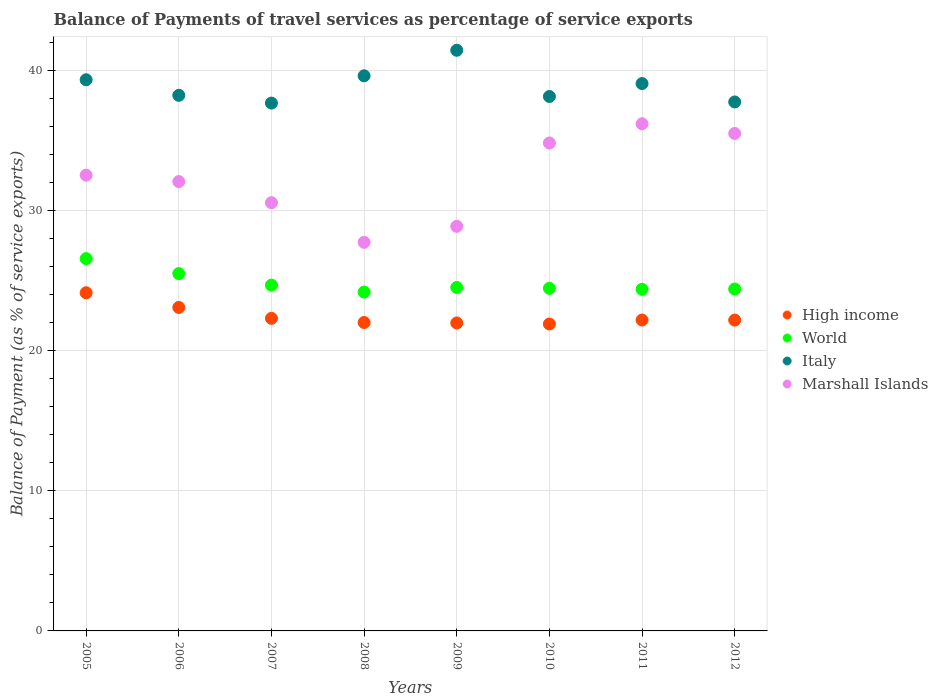How many different coloured dotlines are there?
Your response must be concise. 4. Is the number of dotlines equal to the number of legend labels?
Make the answer very short. Yes. What is the balance of payments of travel services in Italy in 2008?
Your answer should be compact. 39.66. Across all years, what is the maximum balance of payments of travel services in Marshall Islands?
Your response must be concise. 36.23. Across all years, what is the minimum balance of payments of travel services in Marshall Islands?
Make the answer very short. 27.76. What is the total balance of payments of travel services in Marshall Islands in the graph?
Make the answer very short. 258.53. What is the difference between the balance of payments of travel services in World in 2006 and that in 2012?
Make the answer very short. 1.1. What is the difference between the balance of payments of travel services in Italy in 2008 and the balance of payments of travel services in High income in 2012?
Provide a succinct answer. 17.45. What is the average balance of payments of travel services in Italy per year?
Offer a very short reply. 38.94. In the year 2005, what is the difference between the balance of payments of travel services in Marshall Islands and balance of payments of travel services in High income?
Provide a succinct answer. 8.4. In how many years, is the balance of payments of travel services in Italy greater than 34 %?
Provide a short and direct response. 8. What is the ratio of the balance of payments of travel services in High income in 2008 to that in 2010?
Provide a succinct answer. 1. Is the balance of payments of travel services in High income in 2005 less than that in 2011?
Provide a short and direct response. No. What is the difference between the highest and the second highest balance of payments of travel services in World?
Offer a very short reply. 1.07. What is the difference between the highest and the lowest balance of payments of travel services in Italy?
Offer a very short reply. 3.77. In how many years, is the balance of payments of travel services in Italy greater than the average balance of payments of travel services in Italy taken over all years?
Make the answer very short. 4. Is the sum of the balance of payments of travel services in High income in 2005 and 2006 greater than the maximum balance of payments of travel services in Marshall Islands across all years?
Offer a very short reply. Yes. Is it the case that in every year, the sum of the balance of payments of travel services in World and balance of payments of travel services in Marshall Islands  is greater than the sum of balance of payments of travel services in Italy and balance of payments of travel services in High income?
Keep it short and to the point. Yes. Is the balance of payments of travel services in World strictly greater than the balance of payments of travel services in High income over the years?
Give a very brief answer. Yes. How many dotlines are there?
Offer a terse response. 4. How many years are there in the graph?
Your response must be concise. 8. What is the difference between two consecutive major ticks on the Y-axis?
Offer a very short reply. 10. Are the values on the major ticks of Y-axis written in scientific E-notation?
Make the answer very short. No. Does the graph contain grids?
Make the answer very short. Yes. How many legend labels are there?
Ensure brevity in your answer.  4. What is the title of the graph?
Provide a succinct answer. Balance of Payments of travel services as percentage of service exports. What is the label or title of the X-axis?
Offer a terse response. Years. What is the label or title of the Y-axis?
Give a very brief answer. Balance of Payment (as % of service exports). What is the Balance of Payment (as % of service exports) in High income in 2005?
Provide a short and direct response. 24.16. What is the Balance of Payment (as % of service exports) in World in 2005?
Your answer should be very brief. 26.59. What is the Balance of Payment (as % of service exports) in Italy in 2005?
Keep it short and to the point. 39.37. What is the Balance of Payment (as % of service exports) of Marshall Islands in 2005?
Your response must be concise. 32.56. What is the Balance of Payment (as % of service exports) in High income in 2006?
Ensure brevity in your answer.  23.11. What is the Balance of Payment (as % of service exports) in World in 2006?
Make the answer very short. 25.53. What is the Balance of Payment (as % of service exports) in Italy in 2006?
Offer a terse response. 38.26. What is the Balance of Payment (as % of service exports) in Marshall Islands in 2006?
Offer a terse response. 32.1. What is the Balance of Payment (as % of service exports) of High income in 2007?
Give a very brief answer. 22.33. What is the Balance of Payment (as % of service exports) in World in 2007?
Offer a terse response. 24.7. What is the Balance of Payment (as % of service exports) of Italy in 2007?
Ensure brevity in your answer.  37.71. What is the Balance of Payment (as % of service exports) of Marshall Islands in 2007?
Provide a succinct answer. 30.59. What is the Balance of Payment (as % of service exports) of High income in 2008?
Offer a very short reply. 22.03. What is the Balance of Payment (as % of service exports) of World in 2008?
Offer a very short reply. 24.21. What is the Balance of Payment (as % of service exports) of Italy in 2008?
Make the answer very short. 39.66. What is the Balance of Payment (as % of service exports) of Marshall Islands in 2008?
Offer a very short reply. 27.76. What is the Balance of Payment (as % of service exports) in High income in 2009?
Your answer should be compact. 22. What is the Balance of Payment (as % of service exports) in World in 2009?
Offer a terse response. 24.54. What is the Balance of Payment (as % of service exports) of Italy in 2009?
Give a very brief answer. 41.48. What is the Balance of Payment (as % of service exports) in Marshall Islands in 2009?
Offer a very short reply. 28.9. What is the Balance of Payment (as % of service exports) in High income in 2010?
Ensure brevity in your answer.  21.93. What is the Balance of Payment (as % of service exports) of World in 2010?
Provide a succinct answer. 24.47. What is the Balance of Payment (as % of service exports) in Italy in 2010?
Offer a terse response. 38.18. What is the Balance of Payment (as % of service exports) in Marshall Islands in 2010?
Make the answer very short. 34.86. What is the Balance of Payment (as % of service exports) in High income in 2011?
Keep it short and to the point. 22.21. What is the Balance of Payment (as % of service exports) of World in 2011?
Your answer should be very brief. 24.4. What is the Balance of Payment (as % of service exports) in Italy in 2011?
Offer a terse response. 39.1. What is the Balance of Payment (as % of service exports) of Marshall Islands in 2011?
Ensure brevity in your answer.  36.23. What is the Balance of Payment (as % of service exports) of High income in 2012?
Keep it short and to the point. 22.2. What is the Balance of Payment (as % of service exports) of World in 2012?
Your response must be concise. 24.42. What is the Balance of Payment (as % of service exports) in Italy in 2012?
Your response must be concise. 37.79. What is the Balance of Payment (as % of service exports) in Marshall Islands in 2012?
Your answer should be compact. 35.54. Across all years, what is the maximum Balance of Payment (as % of service exports) of High income?
Give a very brief answer. 24.16. Across all years, what is the maximum Balance of Payment (as % of service exports) in World?
Your response must be concise. 26.59. Across all years, what is the maximum Balance of Payment (as % of service exports) in Italy?
Provide a succinct answer. 41.48. Across all years, what is the maximum Balance of Payment (as % of service exports) of Marshall Islands?
Give a very brief answer. 36.23. Across all years, what is the minimum Balance of Payment (as % of service exports) in High income?
Ensure brevity in your answer.  21.93. Across all years, what is the minimum Balance of Payment (as % of service exports) of World?
Provide a succinct answer. 24.21. Across all years, what is the minimum Balance of Payment (as % of service exports) in Italy?
Offer a terse response. 37.71. Across all years, what is the minimum Balance of Payment (as % of service exports) in Marshall Islands?
Give a very brief answer. 27.76. What is the total Balance of Payment (as % of service exports) of High income in the graph?
Provide a short and direct response. 179.97. What is the total Balance of Payment (as % of service exports) of World in the graph?
Your answer should be compact. 198.87. What is the total Balance of Payment (as % of service exports) in Italy in the graph?
Offer a very short reply. 311.55. What is the total Balance of Payment (as % of service exports) of Marshall Islands in the graph?
Your answer should be very brief. 258.53. What is the difference between the Balance of Payment (as % of service exports) of High income in 2005 and that in 2006?
Keep it short and to the point. 1.05. What is the difference between the Balance of Payment (as % of service exports) of World in 2005 and that in 2006?
Your answer should be compact. 1.07. What is the difference between the Balance of Payment (as % of service exports) in Italy in 2005 and that in 2006?
Provide a succinct answer. 1.11. What is the difference between the Balance of Payment (as % of service exports) of Marshall Islands in 2005 and that in 2006?
Offer a very short reply. 0.46. What is the difference between the Balance of Payment (as % of service exports) in High income in 2005 and that in 2007?
Provide a short and direct response. 1.83. What is the difference between the Balance of Payment (as % of service exports) of World in 2005 and that in 2007?
Provide a succinct answer. 1.89. What is the difference between the Balance of Payment (as % of service exports) of Italy in 2005 and that in 2007?
Ensure brevity in your answer.  1.67. What is the difference between the Balance of Payment (as % of service exports) in Marshall Islands in 2005 and that in 2007?
Keep it short and to the point. 1.97. What is the difference between the Balance of Payment (as % of service exports) in High income in 2005 and that in 2008?
Provide a short and direct response. 2.13. What is the difference between the Balance of Payment (as % of service exports) in World in 2005 and that in 2008?
Give a very brief answer. 2.39. What is the difference between the Balance of Payment (as % of service exports) in Italy in 2005 and that in 2008?
Ensure brevity in your answer.  -0.28. What is the difference between the Balance of Payment (as % of service exports) of Marshall Islands in 2005 and that in 2008?
Your answer should be compact. 4.8. What is the difference between the Balance of Payment (as % of service exports) of High income in 2005 and that in 2009?
Give a very brief answer. 2.16. What is the difference between the Balance of Payment (as % of service exports) of World in 2005 and that in 2009?
Keep it short and to the point. 2.06. What is the difference between the Balance of Payment (as % of service exports) in Italy in 2005 and that in 2009?
Ensure brevity in your answer.  -2.11. What is the difference between the Balance of Payment (as % of service exports) of Marshall Islands in 2005 and that in 2009?
Give a very brief answer. 3.65. What is the difference between the Balance of Payment (as % of service exports) in High income in 2005 and that in 2010?
Ensure brevity in your answer.  2.23. What is the difference between the Balance of Payment (as % of service exports) in World in 2005 and that in 2010?
Your response must be concise. 2.12. What is the difference between the Balance of Payment (as % of service exports) in Italy in 2005 and that in 2010?
Ensure brevity in your answer.  1.19. What is the difference between the Balance of Payment (as % of service exports) in Marshall Islands in 2005 and that in 2010?
Give a very brief answer. -2.3. What is the difference between the Balance of Payment (as % of service exports) in High income in 2005 and that in 2011?
Keep it short and to the point. 1.95. What is the difference between the Balance of Payment (as % of service exports) in World in 2005 and that in 2011?
Your answer should be compact. 2.19. What is the difference between the Balance of Payment (as % of service exports) of Italy in 2005 and that in 2011?
Provide a short and direct response. 0.27. What is the difference between the Balance of Payment (as % of service exports) in Marshall Islands in 2005 and that in 2011?
Make the answer very short. -3.67. What is the difference between the Balance of Payment (as % of service exports) of High income in 2005 and that in 2012?
Make the answer very short. 1.95. What is the difference between the Balance of Payment (as % of service exports) of World in 2005 and that in 2012?
Offer a terse response. 2.17. What is the difference between the Balance of Payment (as % of service exports) in Italy in 2005 and that in 2012?
Give a very brief answer. 1.59. What is the difference between the Balance of Payment (as % of service exports) of Marshall Islands in 2005 and that in 2012?
Provide a short and direct response. -2.98. What is the difference between the Balance of Payment (as % of service exports) of High income in 2006 and that in 2007?
Your answer should be very brief. 0.78. What is the difference between the Balance of Payment (as % of service exports) of World in 2006 and that in 2007?
Keep it short and to the point. 0.82. What is the difference between the Balance of Payment (as % of service exports) of Italy in 2006 and that in 2007?
Keep it short and to the point. 0.55. What is the difference between the Balance of Payment (as % of service exports) in Marshall Islands in 2006 and that in 2007?
Offer a terse response. 1.51. What is the difference between the Balance of Payment (as % of service exports) in High income in 2006 and that in 2008?
Ensure brevity in your answer.  1.08. What is the difference between the Balance of Payment (as % of service exports) of World in 2006 and that in 2008?
Your response must be concise. 1.32. What is the difference between the Balance of Payment (as % of service exports) of Italy in 2006 and that in 2008?
Your answer should be compact. -1.4. What is the difference between the Balance of Payment (as % of service exports) in Marshall Islands in 2006 and that in 2008?
Give a very brief answer. 4.34. What is the difference between the Balance of Payment (as % of service exports) in High income in 2006 and that in 2009?
Give a very brief answer. 1.11. What is the difference between the Balance of Payment (as % of service exports) in World in 2006 and that in 2009?
Provide a succinct answer. 0.99. What is the difference between the Balance of Payment (as % of service exports) of Italy in 2006 and that in 2009?
Your answer should be very brief. -3.22. What is the difference between the Balance of Payment (as % of service exports) in Marshall Islands in 2006 and that in 2009?
Offer a very short reply. 3.2. What is the difference between the Balance of Payment (as % of service exports) of High income in 2006 and that in 2010?
Give a very brief answer. 1.18. What is the difference between the Balance of Payment (as % of service exports) in World in 2006 and that in 2010?
Make the answer very short. 1.05. What is the difference between the Balance of Payment (as % of service exports) of Italy in 2006 and that in 2010?
Your answer should be compact. 0.08. What is the difference between the Balance of Payment (as % of service exports) of Marshall Islands in 2006 and that in 2010?
Make the answer very short. -2.76. What is the difference between the Balance of Payment (as % of service exports) in High income in 2006 and that in 2011?
Ensure brevity in your answer.  0.9. What is the difference between the Balance of Payment (as % of service exports) in World in 2006 and that in 2011?
Offer a very short reply. 1.12. What is the difference between the Balance of Payment (as % of service exports) of Italy in 2006 and that in 2011?
Provide a short and direct response. -0.84. What is the difference between the Balance of Payment (as % of service exports) of Marshall Islands in 2006 and that in 2011?
Keep it short and to the point. -4.13. What is the difference between the Balance of Payment (as % of service exports) of High income in 2006 and that in 2012?
Your response must be concise. 0.9. What is the difference between the Balance of Payment (as % of service exports) of World in 2006 and that in 2012?
Provide a succinct answer. 1.1. What is the difference between the Balance of Payment (as % of service exports) of Italy in 2006 and that in 2012?
Offer a very short reply. 0.47. What is the difference between the Balance of Payment (as % of service exports) of Marshall Islands in 2006 and that in 2012?
Your answer should be compact. -3.44. What is the difference between the Balance of Payment (as % of service exports) in High income in 2007 and that in 2008?
Your answer should be very brief. 0.3. What is the difference between the Balance of Payment (as % of service exports) of World in 2007 and that in 2008?
Provide a short and direct response. 0.5. What is the difference between the Balance of Payment (as % of service exports) of Italy in 2007 and that in 2008?
Provide a short and direct response. -1.95. What is the difference between the Balance of Payment (as % of service exports) in Marshall Islands in 2007 and that in 2008?
Your answer should be very brief. 2.83. What is the difference between the Balance of Payment (as % of service exports) in High income in 2007 and that in 2009?
Provide a succinct answer. 0.33. What is the difference between the Balance of Payment (as % of service exports) in World in 2007 and that in 2009?
Your answer should be very brief. 0.17. What is the difference between the Balance of Payment (as % of service exports) of Italy in 2007 and that in 2009?
Offer a terse response. -3.77. What is the difference between the Balance of Payment (as % of service exports) in Marshall Islands in 2007 and that in 2009?
Offer a terse response. 1.69. What is the difference between the Balance of Payment (as % of service exports) in High income in 2007 and that in 2010?
Your answer should be compact. 0.4. What is the difference between the Balance of Payment (as % of service exports) in World in 2007 and that in 2010?
Provide a short and direct response. 0.23. What is the difference between the Balance of Payment (as % of service exports) in Italy in 2007 and that in 2010?
Offer a terse response. -0.47. What is the difference between the Balance of Payment (as % of service exports) of Marshall Islands in 2007 and that in 2010?
Offer a very short reply. -4.27. What is the difference between the Balance of Payment (as % of service exports) of High income in 2007 and that in 2011?
Your answer should be very brief. 0.12. What is the difference between the Balance of Payment (as % of service exports) in World in 2007 and that in 2011?
Provide a succinct answer. 0.3. What is the difference between the Balance of Payment (as % of service exports) of Italy in 2007 and that in 2011?
Ensure brevity in your answer.  -1.39. What is the difference between the Balance of Payment (as % of service exports) in Marshall Islands in 2007 and that in 2011?
Your response must be concise. -5.64. What is the difference between the Balance of Payment (as % of service exports) of High income in 2007 and that in 2012?
Keep it short and to the point. 0.13. What is the difference between the Balance of Payment (as % of service exports) of World in 2007 and that in 2012?
Provide a succinct answer. 0.28. What is the difference between the Balance of Payment (as % of service exports) of Italy in 2007 and that in 2012?
Your answer should be very brief. -0.08. What is the difference between the Balance of Payment (as % of service exports) in Marshall Islands in 2007 and that in 2012?
Make the answer very short. -4.95. What is the difference between the Balance of Payment (as % of service exports) in High income in 2008 and that in 2009?
Ensure brevity in your answer.  0.03. What is the difference between the Balance of Payment (as % of service exports) in World in 2008 and that in 2009?
Provide a short and direct response. -0.33. What is the difference between the Balance of Payment (as % of service exports) of Italy in 2008 and that in 2009?
Provide a succinct answer. -1.82. What is the difference between the Balance of Payment (as % of service exports) of Marshall Islands in 2008 and that in 2009?
Ensure brevity in your answer.  -1.14. What is the difference between the Balance of Payment (as % of service exports) in High income in 2008 and that in 2010?
Your answer should be very brief. 0.11. What is the difference between the Balance of Payment (as % of service exports) of World in 2008 and that in 2010?
Keep it short and to the point. -0.27. What is the difference between the Balance of Payment (as % of service exports) of Italy in 2008 and that in 2010?
Your answer should be compact. 1.48. What is the difference between the Balance of Payment (as % of service exports) of Marshall Islands in 2008 and that in 2010?
Ensure brevity in your answer.  -7.1. What is the difference between the Balance of Payment (as % of service exports) of High income in 2008 and that in 2011?
Your answer should be compact. -0.18. What is the difference between the Balance of Payment (as % of service exports) in World in 2008 and that in 2011?
Provide a succinct answer. -0.19. What is the difference between the Balance of Payment (as % of service exports) in Italy in 2008 and that in 2011?
Keep it short and to the point. 0.56. What is the difference between the Balance of Payment (as % of service exports) in Marshall Islands in 2008 and that in 2011?
Offer a terse response. -8.47. What is the difference between the Balance of Payment (as % of service exports) of High income in 2008 and that in 2012?
Offer a very short reply. -0.17. What is the difference between the Balance of Payment (as % of service exports) of World in 2008 and that in 2012?
Your response must be concise. -0.22. What is the difference between the Balance of Payment (as % of service exports) in Italy in 2008 and that in 2012?
Offer a terse response. 1.87. What is the difference between the Balance of Payment (as % of service exports) in Marshall Islands in 2008 and that in 2012?
Offer a terse response. -7.78. What is the difference between the Balance of Payment (as % of service exports) in High income in 2009 and that in 2010?
Keep it short and to the point. 0.07. What is the difference between the Balance of Payment (as % of service exports) of World in 2009 and that in 2010?
Keep it short and to the point. 0.06. What is the difference between the Balance of Payment (as % of service exports) in Italy in 2009 and that in 2010?
Your answer should be compact. 3.3. What is the difference between the Balance of Payment (as % of service exports) in Marshall Islands in 2009 and that in 2010?
Your answer should be very brief. -5.95. What is the difference between the Balance of Payment (as % of service exports) in High income in 2009 and that in 2011?
Keep it short and to the point. -0.21. What is the difference between the Balance of Payment (as % of service exports) in World in 2009 and that in 2011?
Your answer should be compact. 0.13. What is the difference between the Balance of Payment (as % of service exports) of Italy in 2009 and that in 2011?
Ensure brevity in your answer.  2.38. What is the difference between the Balance of Payment (as % of service exports) in Marshall Islands in 2009 and that in 2011?
Your response must be concise. -7.33. What is the difference between the Balance of Payment (as % of service exports) in High income in 2009 and that in 2012?
Your response must be concise. -0.2. What is the difference between the Balance of Payment (as % of service exports) in World in 2009 and that in 2012?
Keep it short and to the point. 0.11. What is the difference between the Balance of Payment (as % of service exports) of Italy in 2009 and that in 2012?
Ensure brevity in your answer.  3.69. What is the difference between the Balance of Payment (as % of service exports) in Marshall Islands in 2009 and that in 2012?
Keep it short and to the point. -6.64. What is the difference between the Balance of Payment (as % of service exports) of High income in 2010 and that in 2011?
Offer a very short reply. -0.28. What is the difference between the Balance of Payment (as % of service exports) in World in 2010 and that in 2011?
Give a very brief answer. 0.07. What is the difference between the Balance of Payment (as % of service exports) in Italy in 2010 and that in 2011?
Provide a short and direct response. -0.92. What is the difference between the Balance of Payment (as % of service exports) of Marshall Islands in 2010 and that in 2011?
Ensure brevity in your answer.  -1.37. What is the difference between the Balance of Payment (as % of service exports) of High income in 2010 and that in 2012?
Provide a succinct answer. -0.28. What is the difference between the Balance of Payment (as % of service exports) of World in 2010 and that in 2012?
Your response must be concise. 0.05. What is the difference between the Balance of Payment (as % of service exports) in Italy in 2010 and that in 2012?
Your answer should be compact. 0.39. What is the difference between the Balance of Payment (as % of service exports) of Marshall Islands in 2010 and that in 2012?
Offer a very short reply. -0.68. What is the difference between the Balance of Payment (as % of service exports) of High income in 2011 and that in 2012?
Offer a very short reply. 0. What is the difference between the Balance of Payment (as % of service exports) in World in 2011 and that in 2012?
Offer a terse response. -0.02. What is the difference between the Balance of Payment (as % of service exports) of Italy in 2011 and that in 2012?
Give a very brief answer. 1.31. What is the difference between the Balance of Payment (as % of service exports) of Marshall Islands in 2011 and that in 2012?
Offer a very short reply. 0.69. What is the difference between the Balance of Payment (as % of service exports) in High income in 2005 and the Balance of Payment (as % of service exports) in World in 2006?
Provide a succinct answer. -1.37. What is the difference between the Balance of Payment (as % of service exports) of High income in 2005 and the Balance of Payment (as % of service exports) of Italy in 2006?
Your answer should be very brief. -14.1. What is the difference between the Balance of Payment (as % of service exports) of High income in 2005 and the Balance of Payment (as % of service exports) of Marshall Islands in 2006?
Offer a terse response. -7.94. What is the difference between the Balance of Payment (as % of service exports) in World in 2005 and the Balance of Payment (as % of service exports) in Italy in 2006?
Your response must be concise. -11.67. What is the difference between the Balance of Payment (as % of service exports) of World in 2005 and the Balance of Payment (as % of service exports) of Marshall Islands in 2006?
Provide a succinct answer. -5.5. What is the difference between the Balance of Payment (as % of service exports) in Italy in 2005 and the Balance of Payment (as % of service exports) in Marshall Islands in 2006?
Ensure brevity in your answer.  7.27. What is the difference between the Balance of Payment (as % of service exports) in High income in 2005 and the Balance of Payment (as % of service exports) in World in 2007?
Keep it short and to the point. -0.55. What is the difference between the Balance of Payment (as % of service exports) in High income in 2005 and the Balance of Payment (as % of service exports) in Italy in 2007?
Keep it short and to the point. -13.55. What is the difference between the Balance of Payment (as % of service exports) of High income in 2005 and the Balance of Payment (as % of service exports) of Marshall Islands in 2007?
Offer a terse response. -6.43. What is the difference between the Balance of Payment (as % of service exports) of World in 2005 and the Balance of Payment (as % of service exports) of Italy in 2007?
Your response must be concise. -11.11. What is the difference between the Balance of Payment (as % of service exports) in World in 2005 and the Balance of Payment (as % of service exports) in Marshall Islands in 2007?
Provide a succinct answer. -4. What is the difference between the Balance of Payment (as % of service exports) of Italy in 2005 and the Balance of Payment (as % of service exports) of Marshall Islands in 2007?
Your response must be concise. 8.78. What is the difference between the Balance of Payment (as % of service exports) of High income in 2005 and the Balance of Payment (as % of service exports) of World in 2008?
Keep it short and to the point. -0.05. What is the difference between the Balance of Payment (as % of service exports) of High income in 2005 and the Balance of Payment (as % of service exports) of Italy in 2008?
Keep it short and to the point. -15.5. What is the difference between the Balance of Payment (as % of service exports) of High income in 2005 and the Balance of Payment (as % of service exports) of Marshall Islands in 2008?
Keep it short and to the point. -3.6. What is the difference between the Balance of Payment (as % of service exports) in World in 2005 and the Balance of Payment (as % of service exports) in Italy in 2008?
Offer a terse response. -13.06. What is the difference between the Balance of Payment (as % of service exports) in World in 2005 and the Balance of Payment (as % of service exports) in Marshall Islands in 2008?
Offer a terse response. -1.16. What is the difference between the Balance of Payment (as % of service exports) in Italy in 2005 and the Balance of Payment (as % of service exports) in Marshall Islands in 2008?
Keep it short and to the point. 11.61. What is the difference between the Balance of Payment (as % of service exports) of High income in 2005 and the Balance of Payment (as % of service exports) of World in 2009?
Give a very brief answer. -0.38. What is the difference between the Balance of Payment (as % of service exports) in High income in 2005 and the Balance of Payment (as % of service exports) in Italy in 2009?
Offer a very short reply. -17.32. What is the difference between the Balance of Payment (as % of service exports) of High income in 2005 and the Balance of Payment (as % of service exports) of Marshall Islands in 2009?
Give a very brief answer. -4.75. What is the difference between the Balance of Payment (as % of service exports) in World in 2005 and the Balance of Payment (as % of service exports) in Italy in 2009?
Keep it short and to the point. -14.89. What is the difference between the Balance of Payment (as % of service exports) of World in 2005 and the Balance of Payment (as % of service exports) of Marshall Islands in 2009?
Provide a short and direct response. -2.31. What is the difference between the Balance of Payment (as % of service exports) in Italy in 2005 and the Balance of Payment (as % of service exports) in Marshall Islands in 2009?
Give a very brief answer. 10.47. What is the difference between the Balance of Payment (as % of service exports) in High income in 2005 and the Balance of Payment (as % of service exports) in World in 2010?
Keep it short and to the point. -0.32. What is the difference between the Balance of Payment (as % of service exports) of High income in 2005 and the Balance of Payment (as % of service exports) of Italy in 2010?
Provide a short and direct response. -14.02. What is the difference between the Balance of Payment (as % of service exports) in High income in 2005 and the Balance of Payment (as % of service exports) in Marshall Islands in 2010?
Give a very brief answer. -10.7. What is the difference between the Balance of Payment (as % of service exports) in World in 2005 and the Balance of Payment (as % of service exports) in Italy in 2010?
Offer a very short reply. -11.58. What is the difference between the Balance of Payment (as % of service exports) of World in 2005 and the Balance of Payment (as % of service exports) of Marshall Islands in 2010?
Provide a succinct answer. -8.26. What is the difference between the Balance of Payment (as % of service exports) of Italy in 2005 and the Balance of Payment (as % of service exports) of Marshall Islands in 2010?
Make the answer very short. 4.52. What is the difference between the Balance of Payment (as % of service exports) of High income in 2005 and the Balance of Payment (as % of service exports) of World in 2011?
Provide a short and direct response. -0.24. What is the difference between the Balance of Payment (as % of service exports) in High income in 2005 and the Balance of Payment (as % of service exports) in Italy in 2011?
Offer a very short reply. -14.94. What is the difference between the Balance of Payment (as % of service exports) in High income in 2005 and the Balance of Payment (as % of service exports) in Marshall Islands in 2011?
Ensure brevity in your answer.  -12.07. What is the difference between the Balance of Payment (as % of service exports) in World in 2005 and the Balance of Payment (as % of service exports) in Italy in 2011?
Offer a very short reply. -12.51. What is the difference between the Balance of Payment (as % of service exports) of World in 2005 and the Balance of Payment (as % of service exports) of Marshall Islands in 2011?
Your answer should be compact. -9.64. What is the difference between the Balance of Payment (as % of service exports) in Italy in 2005 and the Balance of Payment (as % of service exports) in Marshall Islands in 2011?
Your answer should be compact. 3.14. What is the difference between the Balance of Payment (as % of service exports) of High income in 2005 and the Balance of Payment (as % of service exports) of World in 2012?
Provide a succinct answer. -0.27. What is the difference between the Balance of Payment (as % of service exports) in High income in 2005 and the Balance of Payment (as % of service exports) in Italy in 2012?
Your answer should be very brief. -13.63. What is the difference between the Balance of Payment (as % of service exports) in High income in 2005 and the Balance of Payment (as % of service exports) in Marshall Islands in 2012?
Make the answer very short. -11.38. What is the difference between the Balance of Payment (as % of service exports) in World in 2005 and the Balance of Payment (as % of service exports) in Italy in 2012?
Offer a very short reply. -11.19. What is the difference between the Balance of Payment (as % of service exports) in World in 2005 and the Balance of Payment (as % of service exports) in Marshall Islands in 2012?
Offer a terse response. -8.94. What is the difference between the Balance of Payment (as % of service exports) of Italy in 2005 and the Balance of Payment (as % of service exports) of Marshall Islands in 2012?
Your answer should be compact. 3.84. What is the difference between the Balance of Payment (as % of service exports) of High income in 2006 and the Balance of Payment (as % of service exports) of World in 2007?
Ensure brevity in your answer.  -1.59. What is the difference between the Balance of Payment (as % of service exports) in High income in 2006 and the Balance of Payment (as % of service exports) in Italy in 2007?
Provide a succinct answer. -14.6. What is the difference between the Balance of Payment (as % of service exports) of High income in 2006 and the Balance of Payment (as % of service exports) of Marshall Islands in 2007?
Keep it short and to the point. -7.48. What is the difference between the Balance of Payment (as % of service exports) in World in 2006 and the Balance of Payment (as % of service exports) in Italy in 2007?
Ensure brevity in your answer.  -12.18. What is the difference between the Balance of Payment (as % of service exports) in World in 2006 and the Balance of Payment (as % of service exports) in Marshall Islands in 2007?
Give a very brief answer. -5.06. What is the difference between the Balance of Payment (as % of service exports) of Italy in 2006 and the Balance of Payment (as % of service exports) of Marshall Islands in 2007?
Offer a very short reply. 7.67. What is the difference between the Balance of Payment (as % of service exports) in High income in 2006 and the Balance of Payment (as % of service exports) in World in 2008?
Provide a succinct answer. -1.1. What is the difference between the Balance of Payment (as % of service exports) in High income in 2006 and the Balance of Payment (as % of service exports) in Italy in 2008?
Keep it short and to the point. -16.55. What is the difference between the Balance of Payment (as % of service exports) of High income in 2006 and the Balance of Payment (as % of service exports) of Marshall Islands in 2008?
Your answer should be very brief. -4.65. What is the difference between the Balance of Payment (as % of service exports) in World in 2006 and the Balance of Payment (as % of service exports) in Italy in 2008?
Your answer should be very brief. -14.13. What is the difference between the Balance of Payment (as % of service exports) in World in 2006 and the Balance of Payment (as % of service exports) in Marshall Islands in 2008?
Your answer should be compact. -2.23. What is the difference between the Balance of Payment (as % of service exports) of Italy in 2006 and the Balance of Payment (as % of service exports) of Marshall Islands in 2008?
Provide a short and direct response. 10.5. What is the difference between the Balance of Payment (as % of service exports) of High income in 2006 and the Balance of Payment (as % of service exports) of World in 2009?
Give a very brief answer. -1.43. What is the difference between the Balance of Payment (as % of service exports) of High income in 2006 and the Balance of Payment (as % of service exports) of Italy in 2009?
Keep it short and to the point. -18.37. What is the difference between the Balance of Payment (as % of service exports) in High income in 2006 and the Balance of Payment (as % of service exports) in Marshall Islands in 2009?
Offer a terse response. -5.79. What is the difference between the Balance of Payment (as % of service exports) of World in 2006 and the Balance of Payment (as % of service exports) of Italy in 2009?
Your answer should be very brief. -15.95. What is the difference between the Balance of Payment (as % of service exports) in World in 2006 and the Balance of Payment (as % of service exports) in Marshall Islands in 2009?
Offer a very short reply. -3.38. What is the difference between the Balance of Payment (as % of service exports) in Italy in 2006 and the Balance of Payment (as % of service exports) in Marshall Islands in 2009?
Your answer should be very brief. 9.36. What is the difference between the Balance of Payment (as % of service exports) of High income in 2006 and the Balance of Payment (as % of service exports) of World in 2010?
Offer a terse response. -1.37. What is the difference between the Balance of Payment (as % of service exports) in High income in 2006 and the Balance of Payment (as % of service exports) in Italy in 2010?
Your response must be concise. -15.07. What is the difference between the Balance of Payment (as % of service exports) in High income in 2006 and the Balance of Payment (as % of service exports) in Marshall Islands in 2010?
Keep it short and to the point. -11.75. What is the difference between the Balance of Payment (as % of service exports) of World in 2006 and the Balance of Payment (as % of service exports) of Italy in 2010?
Make the answer very short. -12.65. What is the difference between the Balance of Payment (as % of service exports) in World in 2006 and the Balance of Payment (as % of service exports) in Marshall Islands in 2010?
Offer a very short reply. -9.33. What is the difference between the Balance of Payment (as % of service exports) of Italy in 2006 and the Balance of Payment (as % of service exports) of Marshall Islands in 2010?
Your answer should be compact. 3.4. What is the difference between the Balance of Payment (as % of service exports) in High income in 2006 and the Balance of Payment (as % of service exports) in World in 2011?
Provide a short and direct response. -1.29. What is the difference between the Balance of Payment (as % of service exports) of High income in 2006 and the Balance of Payment (as % of service exports) of Italy in 2011?
Offer a very short reply. -15.99. What is the difference between the Balance of Payment (as % of service exports) of High income in 2006 and the Balance of Payment (as % of service exports) of Marshall Islands in 2011?
Ensure brevity in your answer.  -13.12. What is the difference between the Balance of Payment (as % of service exports) of World in 2006 and the Balance of Payment (as % of service exports) of Italy in 2011?
Your answer should be very brief. -13.57. What is the difference between the Balance of Payment (as % of service exports) of World in 2006 and the Balance of Payment (as % of service exports) of Marshall Islands in 2011?
Keep it short and to the point. -10.7. What is the difference between the Balance of Payment (as % of service exports) of Italy in 2006 and the Balance of Payment (as % of service exports) of Marshall Islands in 2011?
Give a very brief answer. 2.03. What is the difference between the Balance of Payment (as % of service exports) of High income in 2006 and the Balance of Payment (as % of service exports) of World in 2012?
Keep it short and to the point. -1.32. What is the difference between the Balance of Payment (as % of service exports) in High income in 2006 and the Balance of Payment (as % of service exports) in Italy in 2012?
Provide a short and direct response. -14.68. What is the difference between the Balance of Payment (as % of service exports) of High income in 2006 and the Balance of Payment (as % of service exports) of Marshall Islands in 2012?
Your response must be concise. -12.43. What is the difference between the Balance of Payment (as % of service exports) of World in 2006 and the Balance of Payment (as % of service exports) of Italy in 2012?
Your answer should be compact. -12.26. What is the difference between the Balance of Payment (as % of service exports) of World in 2006 and the Balance of Payment (as % of service exports) of Marshall Islands in 2012?
Make the answer very short. -10.01. What is the difference between the Balance of Payment (as % of service exports) of Italy in 2006 and the Balance of Payment (as % of service exports) of Marshall Islands in 2012?
Offer a terse response. 2.72. What is the difference between the Balance of Payment (as % of service exports) in High income in 2007 and the Balance of Payment (as % of service exports) in World in 2008?
Your answer should be very brief. -1.88. What is the difference between the Balance of Payment (as % of service exports) in High income in 2007 and the Balance of Payment (as % of service exports) in Italy in 2008?
Keep it short and to the point. -17.33. What is the difference between the Balance of Payment (as % of service exports) of High income in 2007 and the Balance of Payment (as % of service exports) of Marshall Islands in 2008?
Your answer should be compact. -5.43. What is the difference between the Balance of Payment (as % of service exports) in World in 2007 and the Balance of Payment (as % of service exports) in Italy in 2008?
Make the answer very short. -14.95. What is the difference between the Balance of Payment (as % of service exports) in World in 2007 and the Balance of Payment (as % of service exports) in Marshall Islands in 2008?
Your response must be concise. -3.06. What is the difference between the Balance of Payment (as % of service exports) in Italy in 2007 and the Balance of Payment (as % of service exports) in Marshall Islands in 2008?
Provide a succinct answer. 9.95. What is the difference between the Balance of Payment (as % of service exports) of High income in 2007 and the Balance of Payment (as % of service exports) of World in 2009?
Ensure brevity in your answer.  -2.21. What is the difference between the Balance of Payment (as % of service exports) in High income in 2007 and the Balance of Payment (as % of service exports) in Italy in 2009?
Your response must be concise. -19.15. What is the difference between the Balance of Payment (as % of service exports) in High income in 2007 and the Balance of Payment (as % of service exports) in Marshall Islands in 2009?
Your answer should be very brief. -6.57. What is the difference between the Balance of Payment (as % of service exports) in World in 2007 and the Balance of Payment (as % of service exports) in Italy in 2009?
Provide a succinct answer. -16.78. What is the difference between the Balance of Payment (as % of service exports) in World in 2007 and the Balance of Payment (as % of service exports) in Marshall Islands in 2009?
Provide a short and direct response. -4.2. What is the difference between the Balance of Payment (as % of service exports) in Italy in 2007 and the Balance of Payment (as % of service exports) in Marshall Islands in 2009?
Your answer should be compact. 8.8. What is the difference between the Balance of Payment (as % of service exports) of High income in 2007 and the Balance of Payment (as % of service exports) of World in 2010?
Offer a very short reply. -2.14. What is the difference between the Balance of Payment (as % of service exports) in High income in 2007 and the Balance of Payment (as % of service exports) in Italy in 2010?
Your answer should be very brief. -15.85. What is the difference between the Balance of Payment (as % of service exports) of High income in 2007 and the Balance of Payment (as % of service exports) of Marshall Islands in 2010?
Your response must be concise. -12.53. What is the difference between the Balance of Payment (as % of service exports) in World in 2007 and the Balance of Payment (as % of service exports) in Italy in 2010?
Give a very brief answer. -13.47. What is the difference between the Balance of Payment (as % of service exports) in World in 2007 and the Balance of Payment (as % of service exports) in Marshall Islands in 2010?
Your response must be concise. -10.15. What is the difference between the Balance of Payment (as % of service exports) in Italy in 2007 and the Balance of Payment (as % of service exports) in Marshall Islands in 2010?
Offer a terse response. 2.85. What is the difference between the Balance of Payment (as % of service exports) of High income in 2007 and the Balance of Payment (as % of service exports) of World in 2011?
Your answer should be compact. -2.07. What is the difference between the Balance of Payment (as % of service exports) in High income in 2007 and the Balance of Payment (as % of service exports) in Italy in 2011?
Your answer should be very brief. -16.77. What is the difference between the Balance of Payment (as % of service exports) in High income in 2007 and the Balance of Payment (as % of service exports) in Marshall Islands in 2011?
Provide a short and direct response. -13.9. What is the difference between the Balance of Payment (as % of service exports) of World in 2007 and the Balance of Payment (as % of service exports) of Italy in 2011?
Your response must be concise. -14.4. What is the difference between the Balance of Payment (as % of service exports) of World in 2007 and the Balance of Payment (as % of service exports) of Marshall Islands in 2011?
Provide a short and direct response. -11.53. What is the difference between the Balance of Payment (as % of service exports) of Italy in 2007 and the Balance of Payment (as % of service exports) of Marshall Islands in 2011?
Your answer should be compact. 1.48. What is the difference between the Balance of Payment (as % of service exports) in High income in 2007 and the Balance of Payment (as % of service exports) in World in 2012?
Offer a very short reply. -2.09. What is the difference between the Balance of Payment (as % of service exports) of High income in 2007 and the Balance of Payment (as % of service exports) of Italy in 2012?
Provide a short and direct response. -15.46. What is the difference between the Balance of Payment (as % of service exports) in High income in 2007 and the Balance of Payment (as % of service exports) in Marshall Islands in 2012?
Provide a succinct answer. -13.21. What is the difference between the Balance of Payment (as % of service exports) of World in 2007 and the Balance of Payment (as % of service exports) of Italy in 2012?
Provide a succinct answer. -13.08. What is the difference between the Balance of Payment (as % of service exports) in World in 2007 and the Balance of Payment (as % of service exports) in Marshall Islands in 2012?
Provide a short and direct response. -10.83. What is the difference between the Balance of Payment (as % of service exports) in Italy in 2007 and the Balance of Payment (as % of service exports) in Marshall Islands in 2012?
Provide a short and direct response. 2.17. What is the difference between the Balance of Payment (as % of service exports) in High income in 2008 and the Balance of Payment (as % of service exports) in World in 2009?
Provide a short and direct response. -2.5. What is the difference between the Balance of Payment (as % of service exports) in High income in 2008 and the Balance of Payment (as % of service exports) in Italy in 2009?
Your answer should be compact. -19.45. What is the difference between the Balance of Payment (as % of service exports) in High income in 2008 and the Balance of Payment (as % of service exports) in Marshall Islands in 2009?
Give a very brief answer. -6.87. What is the difference between the Balance of Payment (as % of service exports) in World in 2008 and the Balance of Payment (as % of service exports) in Italy in 2009?
Give a very brief answer. -17.27. What is the difference between the Balance of Payment (as % of service exports) in World in 2008 and the Balance of Payment (as % of service exports) in Marshall Islands in 2009?
Offer a terse response. -4.69. What is the difference between the Balance of Payment (as % of service exports) of Italy in 2008 and the Balance of Payment (as % of service exports) of Marshall Islands in 2009?
Your answer should be compact. 10.75. What is the difference between the Balance of Payment (as % of service exports) in High income in 2008 and the Balance of Payment (as % of service exports) in World in 2010?
Provide a succinct answer. -2.44. What is the difference between the Balance of Payment (as % of service exports) in High income in 2008 and the Balance of Payment (as % of service exports) in Italy in 2010?
Your answer should be very brief. -16.15. What is the difference between the Balance of Payment (as % of service exports) of High income in 2008 and the Balance of Payment (as % of service exports) of Marshall Islands in 2010?
Keep it short and to the point. -12.82. What is the difference between the Balance of Payment (as % of service exports) of World in 2008 and the Balance of Payment (as % of service exports) of Italy in 2010?
Your answer should be very brief. -13.97. What is the difference between the Balance of Payment (as % of service exports) of World in 2008 and the Balance of Payment (as % of service exports) of Marshall Islands in 2010?
Give a very brief answer. -10.65. What is the difference between the Balance of Payment (as % of service exports) of Italy in 2008 and the Balance of Payment (as % of service exports) of Marshall Islands in 2010?
Offer a terse response. 4.8. What is the difference between the Balance of Payment (as % of service exports) of High income in 2008 and the Balance of Payment (as % of service exports) of World in 2011?
Keep it short and to the point. -2.37. What is the difference between the Balance of Payment (as % of service exports) in High income in 2008 and the Balance of Payment (as % of service exports) in Italy in 2011?
Keep it short and to the point. -17.07. What is the difference between the Balance of Payment (as % of service exports) of High income in 2008 and the Balance of Payment (as % of service exports) of Marshall Islands in 2011?
Ensure brevity in your answer.  -14.2. What is the difference between the Balance of Payment (as % of service exports) in World in 2008 and the Balance of Payment (as % of service exports) in Italy in 2011?
Your response must be concise. -14.89. What is the difference between the Balance of Payment (as % of service exports) of World in 2008 and the Balance of Payment (as % of service exports) of Marshall Islands in 2011?
Provide a short and direct response. -12.02. What is the difference between the Balance of Payment (as % of service exports) of Italy in 2008 and the Balance of Payment (as % of service exports) of Marshall Islands in 2011?
Your answer should be compact. 3.43. What is the difference between the Balance of Payment (as % of service exports) in High income in 2008 and the Balance of Payment (as % of service exports) in World in 2012?
Ensure brevity in your answer.  -2.39. What is the difference between the Balance of Payment (as % of service exports) in High income in 2008 and the Balance of Payment (as % of service exports) in Italy in 2012?
Offer a very short reply. -15.76. What is the difference between the Balance of Payment (as % of service exports) of High income in 2008 and the Balance of Payment (as % of service exports) of Marshall Islands in 2012?
Your answer should be compact. -13.51. What is the difference between the Balance of Payment (as % of service exports) in World in 2008 and the Balance of Payment (as % of service exports) in Italy in 2012?
Your answer should be compact. -13.58. What is the difference between the Balance of Payment (as % of service exports) of World in 2008 and the Balance of Payment (as % of service exports) of Marshall Islands in 2012?
Offer a very short reply. -11.33. What is the difference between the Balance of Payment (as % of service exports) of Italy in 2008 and the Balance of Payment (as % of service exports) of Marshall Islands in 2012?
Offer a terse response. 4.12. What is the difference between the Balance of Payment (as % of service exports) in High income in 2009 and the Balance of Payment (as % of service exports) in World in 2010?
Your answer should be very brief. -2.47. What is the difference between the Balance of Payment (as % of service exports) in High income in 2009 and the Balance of Payment (as % of service exports) in Italy in 2010?
Your answer should be compact. -16.18. What is the difference between the Balance of Payment (as % of service exports) of High income in 2009 and the Balance of Payment (as % of service exports) of Marshall Islands in 2010?
Keep it short and to the point. -12.86. What is the difference between the Balance of Payment (as % of service exports) in World in 2009 and the Balance of Payment (as % of service exports) in Italy in 2010?
Provide a succinct answer. -13.64. What is the difference between the Balance of Payment (as % of service exports) of World in 2009 and the Balance of Payment (as % of service exports) of Marshall Islands in 2010?
Offer a very short reply. -10.32. What is the difference between the Balance of Payment (as % of service exports) in Italy in 2009 and the Balance of Payment (as % of service exports) in Marshall Islands in 2010?
Give a very brief answer. 6.62. What is the difference between the Balance of Payment (as % of service exports) of High income in 2009 and the Balance of Payment (as % of service exports) of World in 2011?
Offer a very short reply. -2.4. What is the difference between the Balance of Payment (as % of service exports) in High income in 2009 and the Balance of Payment (as % of service exports) in Italy in 2011?
Make the answer very short. -17.1. What is the difference between the Balance of Payment (as % of service exports) of High income in 2009 and the Balance of Payment (as % of service exports) of Marshall Islands in 2011?
Your response must be concise. -14.23. What is the difference between the Balance of Payment (as % of service exports) of World in 2009 and the Balance of Payment (as % of service exports) of Italy in 2011?
Your answer should be very brief. -14.56. What is the difference between the Balance of Payment (as % of service exports) of World in 2009 and the Balance of Payment (as % of service exports) of Marshall Islands in 2011?
Ensure brevity in your answer.  -11.69. What is the difference between the Balance of Payment (as % of service exports) of Italy in 2009 and the Balance of Payment (as % of service exports) of Marshall Islands in 2011?
Offer a very short reply. 5.25. What is the difference between the Balance of Payment (as % of service exports) in High income in 2009 and the Balance of Payment (as % of service exports) in World in 2012?
Ensure brevity in your answer.  -2.42. What is the difference between the Balance of Payment (as % of service exports) in High income in 2009 and the Balance of Payment (as % of service exports) in Italy in 2012?
Provide a short and direct response. -15.79. What is the difference between the Balance of Payment (as % of service exports) in High income in 2009 and the Balance of Payment (as % of service exports) in Marshall Islands in 2012?
Provide a succinct answer. -13.54. What is the difference between the Balance of Payment (as % of service exports) of World in 2009 and the Balance of Payment (as % of service exports) of Italy in 2012?
Provide a succinct answer. -13.25. What is the difference between the Balance of Payment (as % of service exports) in World in 2009 and the Balance of Payment (as % of service exports) in Marshall Islands in 2012?
Your answer should be very brief. -11. What is the difference between the Balance of Payment (as % of service exports) in Italy in 2009 and the Balance of Payment (as % of service exports) in Marshall Islands in 2012?
Your response must be concise. 5.94. What is the difference between the Balance of Payment (as % of service exports) of High income in 2010 and the Balance of Payment (as % of service exports) of World in 2011?
Your answer should be compact. -2.48. What is the difference between the Balance of Payment (as % of service exports) of High income in 2010 and the Balance of Payment (as % of service exports) of Italy in 2011?
Your answer should be compact. -17.18. What is the difference between the Balance of Payment (as % of service exports) of High income in 2010 and the Balance of Payment (as % of service exports) of Marshall Islands in 2011?
Provide a short and direct response. -14.3. What is the difference between the Balance of Payment (as % of service exports) in World in 2010 and the Balance of Payment (as % of service exports) in Italy in 2011?
Provide a short and direct response. -14.63. What is the difference between the Balance of Payment (as % of service exports) in World in 2010 and the Balance of Payment (as % of service exports) in Marshall Islands in 2011?
Provide a succinct answer. -11.76. What is the difference between the Balance of Payment (as % of service exports) of Italy in 2010 and the Balance of Payment (as % of service exports) of Marshall Islands in 2011?
Ensure brevity in your answer.  1.95. What is the difference between the Balance of Payment (as % of service exports) in High income in 2010 and the Balance of Payment (as % of service exports) in World in 2012?
Offer a very short reply. -2.5. What is the difference between the Balance of Payment (as % of service exports) in High income in 2010 and the Balance of Payment (as % of service exports) in Italy in 2012?
Ensure brevity in your answer.  -15.86. What is the difference between the Balance of Payment (as % of service exports) in High income in 2010 and the Balance of Payment (as % of service exports) in Marshall Islands in 2012?
Offer a terse response. -13.61. What is the difference between the Balance of Payment (as % of service exports) of World in 2010 and the Balance of Payment (as % of service exports) of Italy in 2012?
Provide a short and direct response. -13.31. What is the difference between the Balance of Payment (as % of service exports) in World in 2010 and the Balance of Payment (as % of service exports) in Marshall Islands in 2012?
Give a very brief answer. -11.06. What is the difference between the Balance of Payment (as % of service exports) in Italy in 2010 and the Balance of Payment (as % of service exports) in Marshall Islands in 2012?
Keep it short and to the point. 2.64. What is the difference between the Balance of Payment (as % of service exports) of High income in 2011 and the Balance of Payment (as % of service exports) of World in 2012?
Provide a succinct answer. -2.21. What is the difference between the Balance of Payment (as % of service exports) of High income in 2011 and the Balance of Payment (as % of service exports) of Italy in 2012?
Offer a very short reply. -15.58. What is the difference between the Balance of Payment (as % of service exports) of High income in 2011 and the Balance of Payment (as % of service exports) of Marshall Islands in 2012?
Offer a terse response. -13.33. What is the difference between the Balance of Payment (as % of service exports) of World in 2011 and the Balance of Payment (as % of service exports) of Italy in 2012?
Provide a short and direct response. -13.39. What is the difference between the Balance of Payment (as % of service exports) of World in 2011 and the Balance of Payment (as % of service exports) of Marshall Islands in 2012?
Ensure brevity in your answer.  -11.14. What is the difference between the Balance of Payment (as % of service exports) in Italy in 2011 and the Balance of Payment (as % of service exports) in Marshall Islands in 2012?
Give a very brief answer. 3.56. What is the average Balance of Payment (as % of service exports) in High income per year?
Offer a very short reply. 22.5. What is the average Balance of Payment (as % of service exports) of World per year?
Offer a very short reply. 24.86. What is the average Balance of Payment (as % of service exports) of Italy per year?
Your answer should be compact. 38.94. What is the average Balance of Payment (as % of service exports) in Marshall Islands per year?
Your answer should be very brief. 32.32. In the year 2005, what is the difference between the Balance of Payment (as % of service exports) of High income and Balance of Payment (as % of service exports) of World?
Ensure brevity in your answer.  -2.44. In the year 2005, what is the difference between the Balance of Payment (as % of service exports) of High income and Balance of Payment (as % of service exports) of Italy?
Provide a succinct answer. -15.22. In the year 2005, what is the difference between the Balance of Payment (as % of service exports) in High income and Balance of Payment (as % of service exports) in Marshall Islands?
Make the answer very short. -8.4. In the year 2005, what is the difference between the Balance of Payment (as % of service exports) in World and Balance of Payment (as % of service exports) in Italy?
Keep it short and to the point. -12.78. In the year 2005, what is the difference between the Balance of Payment (as % of service exports) in World and Balance of Payment (as % of service exports) in Marshall Islands?
Give a very brief answer. -5.96. In the year 2005, what is the difference between the Balance of Payment (as % of service exports) of Italy and Balance of Payment (as % of service exports) of Marshall Islands?
Offer a very short reply. 6.82. In the year 2006, what is the difference between the Balance of Payment (as % of service exports) in High income and Balance of Payment (as % of service exports) in World?
Provide a succinct answer. -2.42. In the year 2006, what is the difference between the Balance of Payment (as % of service exports) in High income and Balance of Payment (as % of service exports) in Italy?
Give a very brief answer. -15.15. In the year 2006, what is the difference between the Balance of Payment (as % of service exports) of High income and Balance of Payment (as % of service exports) of Marshall Islands?
Keep it short and to the point. -8.99. In the year 2006, what is the difference between the Balance of Payment (as % of service exports) in World and Balance of Payment (as % of service exports) in Italy?
Make the answer very short. -12.73. In the year 2006, what is the difference between the Balance of Payment (as % of service exports) of World and Balance of Payment (as % of service exports) of Marshall Islands?
Your answer should be compact. -6.57. In the year 2006, what is the difference between the Balance of Payment (as % of service exports) in Italy and Balance of Payment (as % of service exports) in Marshall Islands?
Your answer should be very brief. 6.16. In the year 2007, what is the difference between the Balance of Payment (as % of service exports) of High income and Balance of Payment (as % of service exports) of World?
Provide a succinct answer. -2.37. In the year 2007, what is the difference between the Balance of Payment (as % of service exports) of High income and Balance of Payment (as % of service exports) of Italy?
Make the answer very short. -15.38. In the year 2007, what is the difference between the Balance of Payment (as % of service exports) in High income and Balance of Payment (as % of service exports) in Marshall Islands?
Your answer should be compact. -8.26. In the year 2007, what is the difference between the Balance of Payment (as % of service exports) of World and Balance of Payment (as % of service exports) of Italy?
Your answer should be compact. -13. In the year 2007, what is the difference between the Balance of Payment (as % of service exports) in World and Balance of Payment (as % of service exports) in Marshall Islands?
Make the answer very short. -5.89. In the year 2007, what is the difference between the Balance of Payment (as % of service exports) of Italy and Balance of Payment (as % of service exports) of Marshall Islands?
Provide a succinct answer. 7.12. In the year 2008, what is the difference between the Balance of Payment (as % of service exports) in High income and Balance of Payment (as % of service exports) in World?
Offer a very short reply. -2.18. In the year 2008, what is the difference between the Balance of Payment (as % of service exports) in High income and Balance of Payment (as % of service exports) in Italy?
Provide a succinct answer. -17.62. In the year 2008, what is the difference between the Balance of Payment (as % of service exports) in High income and Balance of Payment (as % of service exports) in Marshall Islands?
Your answer should be very brief. -5.73. In the year 2008, what is the difference between the Balance of Payment (as % of service exports) of World and Balance of Payment (as % of service exports) of Italy?
Ensure brevity in your answer.  -15.45. In the year 2008, what is the difference between the Balance of Payment (as % of service exports) of World and Balance of Payment (as % of service exports) of Marshall Islands?
Your response must be concise. -3.55. In the year 2008, what is the difference between the Balance of Payment (as % of service exports) in Italy and Balance of Payment (as % of service exports) in Marshall Islands?
Offer a very short reply. 11.9. In the year 2009, what is the difference between the Balance of Payment (as % of service exports) of High income and Balance of Payment (as % of service exports) of World?
Provide a short and direct response. -2.54. In the year 2009, what is the difference between the Balance of Payment (as % of service exports) in High income and Balance of Payment (as % of service exports) in Italy?
Provide a succinct answer. -19.48. In the year 2009, what is the difference between the Balance of Payment (as % of service exports) of High income and Balance of Payment (as % of service exports) of Marshall Islands?
Ensure brevity in your answer.  -6.9. In the year 2009, what is the difference between the Balance of Payment (as % of service exports) in World and Balance of Payment (as % of service exports) in Italy?
Keep it short and to the point. -16.94. In the year 2009, what is the difference between the Balance of Payment (as % of service exports) of World and Balance of Payment (as % of service exports) of Marshall Islands?
Your answer should be compact. -4.37. In the year 2009, what is the difference between the Balance of Payment (as % of service exports) in Italy and Balance of Payment (as % of service exports) in Marshall Islands?
Keep it short and to the point. 12.58. In the year 2010, what is the difference between the Balance of Payment (as % of service exports) of High income and Balance of Payment (as % of service exports) of World?
Ensure brevity in your answer.  -2.55. In the year 2010, what is the difference between the Balance of Payment (as % of service exports) in High income and Balance of Payment (as % of service exports) in Italy?
Your answer should be very brief. -16.25. In the year 2010, what is the difference between the Balance of Payment (as % of service exports) in High income and Balance of Payment (as % of service exports) in Marshall Islands?
Your answer should be very brief. -12.93. In the year 2010, what is the difference between the Balance of Payment (as % of service exports) in World and Balance of Payment (as % of service exports) in Italy?
Your response must be concise. -13.7. In the year 2010, what is the difference between the Balance of Payment (as % of service exports) of World and Balance of Payment (as % of service exports) of Marshall Islands?
Offer a terse response. -10.38. In the year 2010, what is the difference between the Balance of Payment (as % of service exports) of Italy and Balance of Payment (as % of service exports) of Marshall Islands?
Your response must be concise. 3.32. In the year 2011, what is the difference between the Balance of Payment (as % of service exports) in High income and Balance of Payment (as % of service exports) in World?
Give a very brief answer. -2.19. In the year 2011, what is the difference between the Balance of Payment (as % of service exports) of High income and Balance of Payment (as % of service exports) of Italy?
Keep it short and to the point. -16.89. In the year 2011, what is the difference between the Balance of Payment (as % of service exports) in High income and Balance of Payment (as % of service exports) in Marshall Islands?
Your response must be concise. -14.02. In the year 2011, what is the difference between the Balance of Payment (as % of service exports) in World and Balance of Payment (as % of service exports) in Italy?
Ensure brevity in your answer.  -14.7. In the year 2011, what is the difference between the Balance of Payment (as % of service exports) of World and Balance of Payment (as % of service exports) of Marshall Islands?
Keep it short and to the point. -11.83. In the year 2011, what is the difference between the Balance of Payment (as % of service exports) in Italy and Balance of Payment (as % of service exports) in Marshall Islands?
Provide a succinct answer. 2.87. In the year 2012, what is the difference between the Balance of Payment (as % of service exports) in High income and Balance of Payment (as % of service exports) in World?
Your answer should be very brief. -2.22. In the year 2012, what is the difference between the Balance of Payment (as % of service exports) of High income and Balance of Payment (as % of service exports) of Italy?
Offer a very short reply. -15.58. In the year 2012, what is the difference between the Balance of Payment (as % of service exports) in High income and Balance of Payment (as % of service exports) in Marshall Islands?
Give a very brief answer. -13.33. In the year 2012, what is the difference between the Balance of Payment (as % of service exports) in World and Balance of Payment (as % of service exports) in Italy?
Keep it short and to the point. -13.36. In the year 2012, what is the difference between the Balance of Payment (as % of service exports) in World and Balance of Payment (as % of service exports) in Marshall Islands?
Keep it short and to the point. -11.11. In the year 2012, what is the difference between the Balance of Payment (as % of service exports) in Italy and Balance of Payment (as % of service exports) in Marshall Islands?
Your answer should be very brief. 2.25. What is the ratio of the Balance of Payment (as % of service exports) in High income in 2005 to that in 2006?
Make the answer very short. 1.05. What is the ratio of the Balance of Payment (as % of service exports) of World in 2005 to that in 2006?
Offer a very short reply. 1.04. What is the ratio of the Balance of Payment (as % of service exports) of Italy in 2005 to that in 2006?
Give a very brief answer. 1.03. What is the ratio of the Balance of Payment (as % of service exports) of Marshall Islands in 2005 to that in 2006?
Ensure brevity in your answer.  1.01. What is the ratio of the Balance of Payment (as % of service exports) in High income in 2005 to that in 2007?
Provide a succinct answer. 1.08. What is the ratio of the Balance of Payment (as % of service exports) of World in 2005 to that in 2007?
Provide a succinct answer. 1.08. What is the ratio of the Balance of Payment (as % of service exports) of Italy in 2005 to that in 2007?
Keep it short and to the point. 1.04. What is the ratio of the Balance of Payment (as % of service exports) of Marshall Islands in 2005 to that in 2007?
Keep it short and to the point. 1.06. What is the ratio of the Balance of Payment (as % of service exports) of High income in 2005 to that in 2008?
Give a very brief answer. 1.1. What is the ratio of the Balance of Payment (as % of service exports) in World in 2005 to that in 2008?
Your answer should be very brief. 1.1. What is the ratio of the Balance of Payment (as % of service exports) in Italy in 2005 to that in 2008?
Provide a succinct answer. 0.99. What is the ratio of the Balance of Payment (as % of service exports) in Marshall Islands in 2005 to that in 2008?
Offer a very short reply. 1.17. What is the ratio of the Balance of Payment (as % of service exports) in High income in 2005 to that in 2009?
Provide a short and direct response. 1.1. What is the ratio of the Balance of Payment (as % of service exports) of World in 2005 to that in 2009?
Ensure brevity in your answer.  1.08. What is the ratio of the Balance of Payment (as % of service exports) in Italy in 2005 to that in 2009?
Give a very brief answer. 0.95. What is the ratio of the Balance of Payment (as % of service exports) of Marshall Islands in 2005 to that in 2009?
Offer a very short reply. 1.13. What is the ratio of the Balance of Payment (as % of service exports) in High income in 2005 to that in 2010?
Make the answer very short. 1.1. What is the ratio of the Balance of Payment (as % of service exports) of World in 2005 to that in 2010?
Offer a terse response. 1.09. What is the ratio of the Balance of Payment (as % of service exports) of Italy in 2005 to that in 2010?
Provide a succinct answer. 1.03. What is the ratio of the Balance of Payment (as % of service exports) of Marshall Islands in 2005 to that in 2010?
Offer a very short reply. 0.93. What is the ratio of the Balance of Payment (as % of service exports) in High income in 2005 to that in 2011?
Make the answer very short. 1.09. What is the ratio of the Balance of Payment (as % of service exports) of World in 2005 to that in 2011?
Your response must be concise. 1.09. What is the ratio of the Balance of Payment (as % of service exports) in Marshall Islands in 2005 to that in 2011?
Provide a succinct answer. 0.9. What is the ratio of the Balance of Payment (as % of service exports) in High income in 2005 to that in 2012?
Keep it short and to the point. 1.09. What is the ratio of the Balance of Payment (as % of service exports) in World in 2005 to that in 2012?
Offer a very short reply. 1.09. What is the ratio of the Balance of Payment (as % of service exports) in Italy in 2005 to that in 2012?
Give a very brief answer. 1.04. What is the ratio of the Balance of Payment (as % of service exports) of Marshall Islands in 2005 to that in 2012?
Make the answer very short. 0.92. What is the ratio of the Balance of Payment (as % of service exports) of High income in 2006 to that in 2007?
Provide a short and direct response. 1.03. What is the ratio of the Balance of Payment (as % of service exports) in Italy in 2006 to that in 2007?
Provide a succinct answer. 1.01. What is the ratio of the Balance of Payment (as % of service exports) of Marshall Islands in 2006 to that in 2007?
Make the answer very short. 1.05. What is the ratio of the Balance of Payment (as % of service exports) of High income in 2006 to that in 2008?
Your answer should be very brief. 1.05. What is the ratio of the Balance of Payment (as % of service exports) of World in 2006 to that in 2008?
Keep it short and to the point. 1.05. What is the ratio of the Balance of Payment (as % of service exports) in Italy in 2006 to that in 2008?
Give a very brief answer. 0.96. What is the ratio of the Balance of Payment (as % of service exports) of Marshall Islands in 2006 to that in 2008?
Provide a succinct answer. 1.16. What is the ratio of the Balance of Payment (as % of service exports) of High income in 2006 to that in 2009?
Keep it short and to the point. 1.05. What is the ratio of the Balance of Payment (as % of service exports) of World in 2006 to that in 2009?
Offer a very short reply. 1.04. What is the ratio of the Balance of Payment (as % of service exports) of Italy in 2006 to that in 2009?
Provide a succinct answer. 0.92. What is the ratio of the Balance of Payment (as % of service exports) in Marshall Islands in 2006 to that in 2009?
Ensure brevity in your answer.  1.11. What is the ratio of the Balance of Payment (as % of service exports) in High income in 2006 to that in 2010?
Your answer should be compact. 1.05. What is the ratio of the Balance of Payment (as % of service exports) of World in 2006 to that in 2010?
Ensure brevity in your answer.  1.04. What is the ratio of the Balance of Payment (as % of service exports) of Marshall Islands in 2006 to that in 2010?
Offer a terse response. 0.92. What is the ratio of the Balance of Payment (as % of service exports) of High income in 2006 to that in 2011?
Offer a terse response. 1.04. What is the ratio of the Balance of Payment (as % of service exports) of World in 2006 to that in 2011?
Ensure brevity in your answer.  1.05. What is the ratio of the Balance of Payment (as % of service exports) of Italy in 2006 to that in 2011?
Keep it short and to the point. 0.98. What is the ratio of the Balance of Payment (as % of service exports) of Marshall Islands in 2006 to that in 2011?
Your answer should be very brief. 0.89. What is the ratio of the Balance of Payment (as % of service exports) of High income in 2006 to that in 2012?
Give a very brief answer. 1.04. What is the ratio of the Balance of Payment (as % of service exports) in World in 2006 to that in 2012?
Your answer should be very brief. 1.05. What is the ratio of the Balance of Payment (as % of service exports) of Italy in 2006 to that in 2012?
Provide a succinct answer. 1.01. What is the ratio of the Balance of Payment (as % of service exports) in Marshall Islands in 2006 to that in 2012?
Keep it short and to the point. 0.9. What is the ratio of the Balance of Payment (as % of service exports) of High income in 2007 to that in 2008?
Keep it short and to the point. 1.01. What is the ratio of the Balance of Payment (as % of service exports) in World in 2007 to that in 2008?
Offer a terse response. 1.02. What is the ratio of the Balance of Payment (as % of service exports) of Italy in 2007 to that in 2008?
Your answer should be compact. 0.95. What is the ratio of the Balance of Payment (as % of service exports) of Marshall Islands in 2007 to that in 2008?
Keep it short and to the point. 1.1. What is the ratio of the Balance of Payment (as % of service exports) in World in 2007 to that in 2009?
Give a very brief answer. 1.01. What is the ratio of the Balance of Payment (as % of service exports) of Italy in 2007 to that in 2009?
Make the answer very short. 0.91. What is the ratio of the Balance of Payment (as % of service exports) in Marshall Islands in 2007 to that in 2009?
Offer a very short reply. 1.06. What is the ratio of the Balance of Payment (as % of service exports) in High income in 2007 to that in 2010?
Offer a terse response. 1.02. What is the ratio of the Balance of Payment (as % of service exports) of World in 2007 to that in 2010?
Give a very brief answer. 1.01. What is the ratio of the Balance of Payment (as % of service exports) of Italy in 2007 to that in 2010?
Offer a very short reply. 0.99. What is the ratio of the Balance of Payment (as % of service exports) in Marshall Islands in 2007 to that in 2010?
Provide a succinct answer. 0.88. What is the ratio of the Balance of Payment (as % of service exports) of High income in 2007 to that in 2011?
Provide a succinct answer. 1.01. What is the ratio of the Balance of Payment (as % of service exports) in World in 2007 to that in 2011?
Make the answer very short. 1.01. What is the ratio of the Balance of Payment (as % of service exports) of Italy in 2007 to that in 2011?
Give a very brief answer. 0.96. What is the ratio of the Balance of Payment (as % of service exports) of Marshall Islands in 2007 to that in 2011?
Your answer should be very brief. 0.84. What is the ratio of the Balance of Payment (as % of service exports) in High income in 2007 to that in 2012?
Offer a very short reply. 1.01. What is the ratio of the Balance of Payment (as % of service exports) of World in 2007 to that in 2012?
Ensure brevity in your answer.  1.01. What is the ratio of the Balance of Payment (as % of service exports) in Marshall Islands in 2007 to that in 2012?
Give a very brief answer. 0.86. What is the ratio of the Balance of Payment (as % of service exports) in High income in 2008 to that in 2009?
Keep it short and to the point. 1. What is the ratio of the Balance of Payment (as % of service exports) of World in 2008 to that in 2009?
Offer a terse response. 0.99. What is the ratio of the Balance of Payment (as % of service exports) of Italy in 2008 to that in 2009?
Ensure brevity in your answer.  0.96. What is the ratio of the Balance of Payment (as % of service exports) of Marshall Islands in 2008 to that in 2009?
Offer a very short reply. 0.96. What is the ratio of the Balance of Payment (as % of service exports) in High income in 2008 to that in 2010?
Keep it short and to the point. 1. What is the ratio of the Balance of Payment (as % of service exports) in Italy in 2008 to that in 2010?
Your answer should be compact. 1.04. What is the ratio of the Balance of Payment (as % of service exports) of Marshall Islands in 2008 to that in 2010?
Make the answer very short. 0.8. What is the ratio of the Balance of Payment (as % of service exports) of Italy in 2008 to that in 2011?
Make the answer very short. 1.01. What is the ratio of the Balance of Payment (as % of service exports) of Marshall Islands in 2008 to that in 2011?
Offer a very short reply. 0.77. What is the ratio of the Balance of Payment (as % of service exports) of World in 2008 to that in 2012?
Your answer should be very brief. 0.99. What is the ratio of the Balance of Payment (as % of service exports) in Italy in 2008 to that in 2012?
Your answer should be compact. 1.05. What is the ratio of the Balance of Payment (as % of service exports) in Marshall Islands in 2008 to that in 2012?
Provide a succinct answer. 0.78. What is the ratio of the Balance of Payment (as % of service exports) of World in 2009 to that in 2010?
Your response must be concise. 1. What is the ratio of the Balance of Payment (as % of service exports) of Italy in 2009 to that in 2010?
Keep it short and to the point. 1.09. What is the ratio of the Balance of Payment (as % of service exports) of Marshall Islands in 2009 to that in 2010?
Give a very brief answer. 0.83. What is the ratio of the Balance of Payment (as % of service exports) in High income in 2009 to that in 2011?
Your answer should be very brief. 0.99. What is the ratio of the Balance of Payment (as % of service exports) in World in 2009 to that in 2011?
Give a very brief answer. 1.01. What is the ratio of the Balance of Payment (as % of service exports) in Italy in 2009 to that in 2011?
Ensure brevity in your answer.  1.06. What is the ratio of the Balance of Payment (as % of service exports) in Marshall Islands in 2009 to that in 2011?
Provide a succinct answer. 0.8. What is the ratio of the Balance of Payment (as % of service exports) of High income in 2009 to that in 2012?
Ensure brevity in your answer.  0.99. What is the ratio of the Balance of Payment (as % of service exports) in Italy in 2009 to that in 2012?
Provide a short and direct response. 1.1. What is the ratio of the Balance of Payment (as % of service exports) in Marshall Islands in 2009 to that in 2012?
Make the answer very short. 0.81. What is the ratio of the Balance of Payment (as % of service exports) in High income in 2010 to that in 2011?
Make the answer very short. 0.99. What is the ratio of the Balance of Payment (as % of service exports) of World in 2010 to that in 2011?
Ensure brevity in your answer.  1. What is the ratio of the Balance of Payment (as % of service exports) of Italy in 2010 to that in 2011?
Provide a succinct answer. 0.98. What is the ratio of the Balance of Payment (as % of service exports) of Marshall Islands in 2010 to that in 2011?
Ensure brevity in your answer.  0.96. What is the ratio of the Balance of Payment (as % of service exports) in High income in 2010 to that in 2012?
Provide a short and direct response. 0.99. What is the ratio of the Balance of Payment (as % of service exports) of Italy in 2010 to that in 2012?
Your response must be concise. 1.01. What is the ratio of the Balance of Payment (as % of service exports) in Marshall Islands in 2010 to that in 2012?
Give a very brief answer. 0.98. What is the ratio of the Balance of Payment (as % of service exports) of Italy in 2011 to that in 2012?
Offer a terse response. 1.03. What is the ratio of the Balance of Payment (as % of service exports) in Marshall Islands in 2011 to that in 2012?
Ensure brevity in your answer.  1.02. What is the difference between the highest and the second highest Balance of Payment (as % of service exports) in High income?
Provide a short and direct response. 1.05. What is the difference between the highest and the second highest Balance of Payment (as % of service exports) of World?
Offer a terse response. 1.07. What is the difference between the highest and the second highest Balance of Payment (as % of service exports) of Italy?
Your answer should be compact. 1.82. What is the difference between the highest and the second highest Balance of Payment (as % of service exports) in Marshall Islands?
Your response must be concise. 0.69. What is the difference between the highest and the lowest Balance of Payment (as % of service exports) of High income?
Your answer should be very brief. 2.23. What is the difference between the highest and the lowest Balance of Payment (as % of service exports) in World?
Provide a short and direct response. 2.39. What is the difference between the highest and the lowest Balance of Payment (as % of service exports) in Italy?
Offer a very short reply. 3.77. What is the difference between the highest and the lowest Balance of Payment (as % of service exports) of Marshall Islands?
Provide a short and direct response. 8.47. 